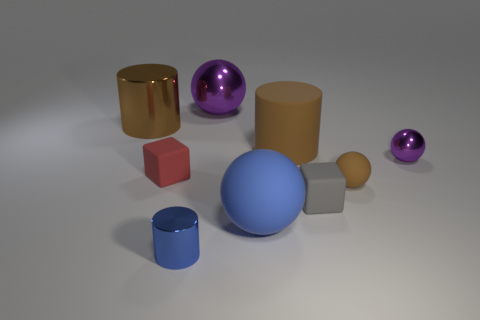Add 1 tiny shiny spheres. How many objects exist? 10 Subtract all cylinders. How many objects are left? 6 Add 9 red rubber things. How many red rubber things exist? 10 Subtract 0 yellow cylinders. How many objects are left? 9 Subtract all cyan cubes. Subtract all big blue rubber things. How many objects are left? 8 Add 7 tiny blue things. How many tiny blue things are left? 8 